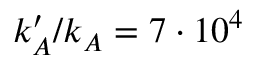Convert formula to latex. <formula><loc_0><loc_0><loc_500><loc_500>k _ { A } ^ { \prime } / k _ { A } = 7 \cdot 1 0 ^ { 4 }</formula> 